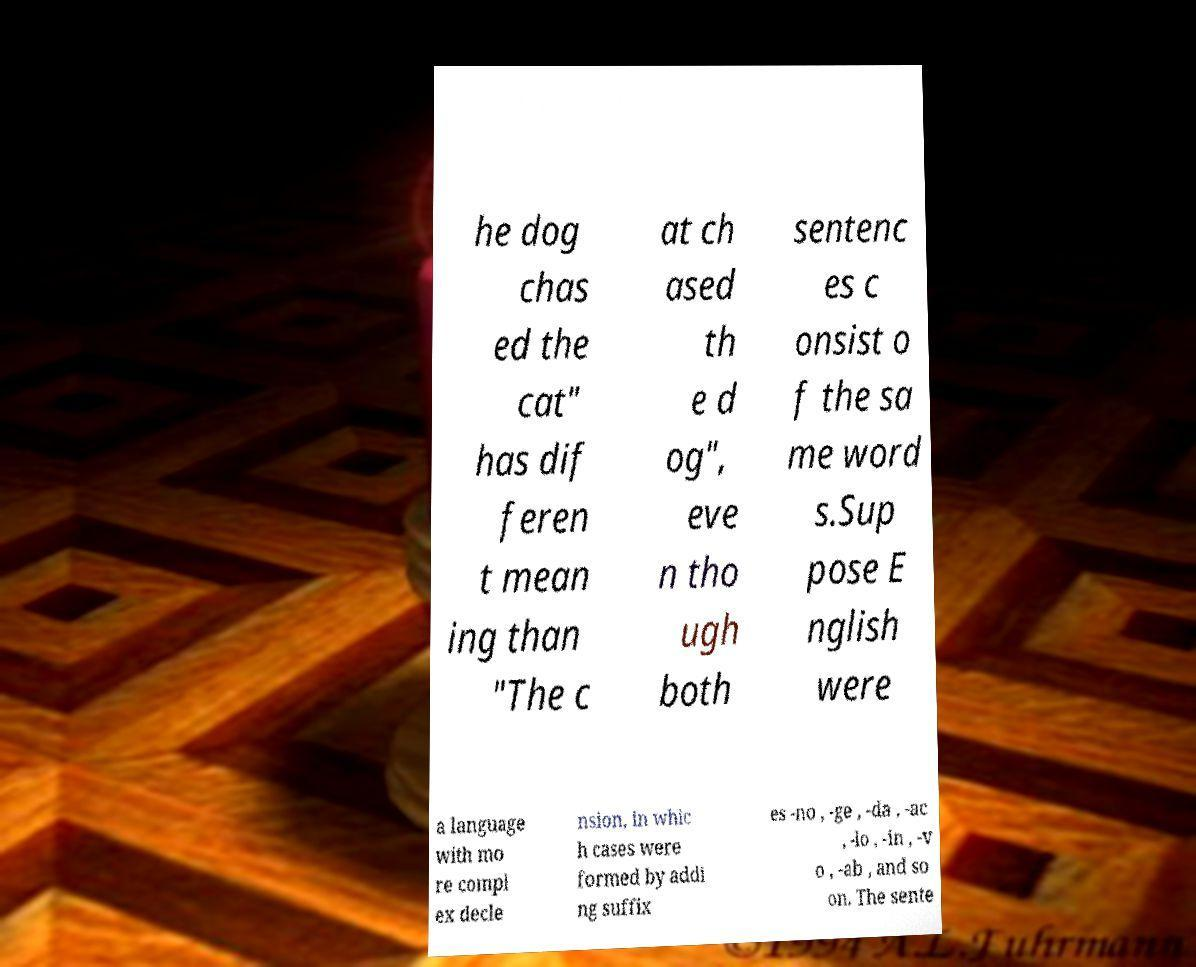For documentation purposes, I need the text within this image transcribed. Could you provide that? he dog chas ed the cat" has dif feren t mean ing than "The c at ch ased th e d og", eve n tho ugh both sentenc es c onsist o f the sa me word s.Sup pose E nglish were a language with mo re compl ex decle nsion, in whic h cases were formed by addi ng suffix es -no , -ge , -da , -ac , -lo , -in , -v o , -ab , and so on. The sente 